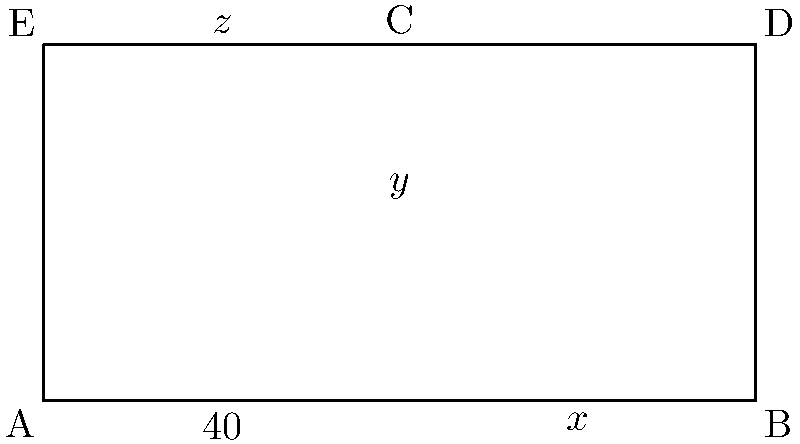In the diagram above, lines ED and AB are parallel. Given that the angle at A is 40°, determine the values of x, y, and z. Show all your work and explain each step clearly. Remember, precision is key in geometry, just as it is in overcoming life's challenges. Let's approach this step-by-step:

1) Since ED and AB are parallel, the alternate interior angles are equal. Therefore, $\angle BAE = \angle AED = 40°$.

2) In triangle AEC:
   - We know $\angle BAE = 40°$
   - The sum of angles in a triangle is always 180°
   - So, $40° + y° + z° = 180°$

3) In the quadrilateral ABDE:
   - The sum of angles in a quadrilateral is always 360°
   - We know two angles: $\angle BAE = 40°$ and $\angle AED = 40°$
   - So, $40° + x° + 40° + z° = 360°$
   - Simplifying: $x° + z° = 280°$

4) From steps 2 and 3, we have two equations:
   $y° + z° = 140°$ (from step 2)
   $x° + z° = 280°$ (from step 3)

5) Subtracting the first equation from the second:
   $x° - y° = 140°$

6) Since angle ACB is an exterior angle of triangle AEC, it's equal to the sum of the two non-adjacent interior angles:
   $x° = y° + 40°$

7) Substituting this into the equation from step 5:
   $(y° + 40°) - y° = 140°$
   $40° = 140°$
   $y° = 100°$

8) Now we can find x:
   $x° = y° + 40° = 100° + 40° = 140°$

9) And finally, z:
   $z° = 180° - 40° - y° = 180° - 40° - 100° = 40°$

Therefore, $x = 140°$, $y = 100°$, and $z = 40°$.
Answer: $x = 140°$, $y = 100°$, $z = 40°$ 